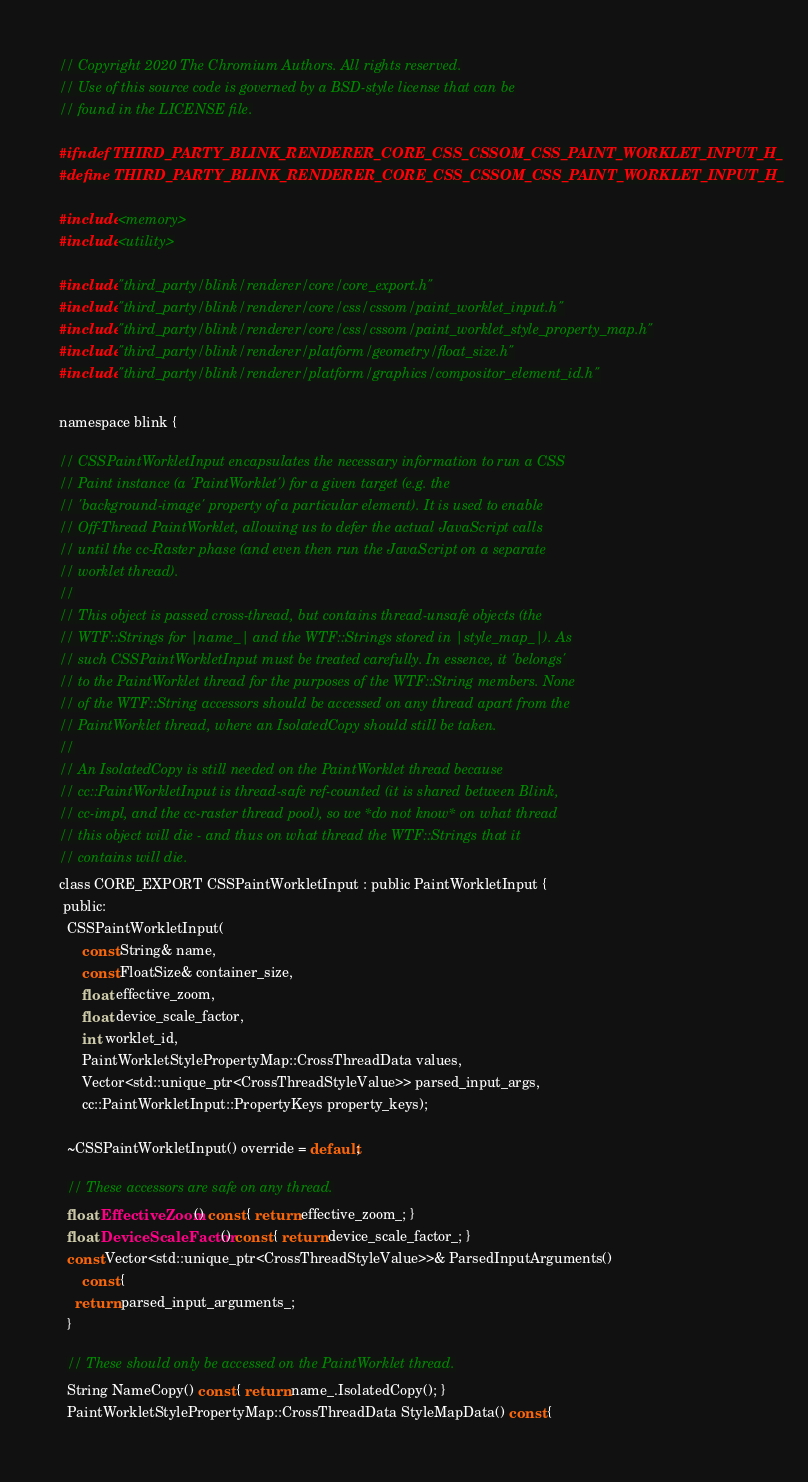Convert code to text. <code><loc_0><loc_0><loc_500><loc_500><_C_>// Copyright 2020 The Chromium Authors. All rights reserved.
// Use of this source code is governed by a BSD-style license that can be
// found in the LICENSE file.

#ifndef THIRD_PARTY_BLINK_RENDERER_CORE_CSS_CSSOM_CSS_PAINT_WORKLET_INPUT_H_
#define THIRD_PARTY_BLINK_RENDERER_CORE_CSS_CSSOM_CSS_PAINT_WORKLET_INPUT_H_

#include <memory>
#include <utility>

#include "third_party/blink/renderer/core/core_export.h"
#include "third_party/blink/renderer/core/css/cssom/paint_worklet_input.h"
#include "third_party/blink/renderer/core/css/cssom/paint_worklet_style_property_map.h"
#include "third_party/blink/renderer/platform/geometry/float_size.h"
#include "third_party/blink/renderer/platform/graphics/compositor_element_id.h"

namespace blink {

// CSSPaintWorkletInput encapsulates the necessary information to run a CSS
// Paint instance (a 'PaintWorklet') for a given target (e.g. the
// 'background-image' property of a particular element). It is used to enable
// Off-Thread PaintWorklet, allowing us to defer the actual JavaScript calls
// until the cc-Raster phase (and even then run the JavaScript on a separate
// worklet thread).
//
// This object is passed cross-thread, but contains thread-unsafe objects (the
// WTF::Strings for |name_| and the WTF::Strings stored in |style_map_|). As
// such CSSPaintWorkletInput must be treated carefully. In essence, it 'belongs'
// to the PaintWorklet thread for the purposes of the WTF::String members. None
// of the WTF::String accessors should be accessed on any thread apart from the
// PaintWorklet thread, where an IsolatedCopy should still be taken.
//
// An IsolatedCopy is still needed on the PaintWorklet thread because
// cc::PaintWorkletInput is thread-safe ref-counted (it is shared between Blink,
// cc-impl, and the cc-raster thread pool), so we *do not know* on what thread
// this object will die - and thus on what thread the WTF::Strings that it
// contains will die.
class CORE_EXPORT CSSPaintWorkletInput : public PaintWorkletInput {
 public:
  CSSPaintWorkletInput(
      const String& name,
      const FloatSize& container_size,
      float effective_zoom,
      float device_scale_factor,
      int worklet_id,
      PaintWorkletStylePropertyMap::CrossThreadData values,
      Vector<std::unique_ptr<CrossThreadStyleValue>> parsed_input_args,
      cc::PaintWorkletInput::PropertyKeys property_keys);

  ~CSSPaintWorkletInput() override = default;

  // These accessors are safe on any thread.
  float EffectiveZoom() const { return effective_zoom_; }
  float DeviceScaleFactor() const { return device_scale_factor_; }
  const Vector<std::unique_ptr<CrossThreadStyleValue>>& ParsedInputArguments()
      const {
    return parsed_input_arguments_;
  }

  // These should only be accessed on the PaintWorklet thread.
  String NameCopy() const { return name_.IsolatedCopy(); }
  PaintWorkletStylePropertyMap::CrossThreadData StyleMapData() const {</code> 